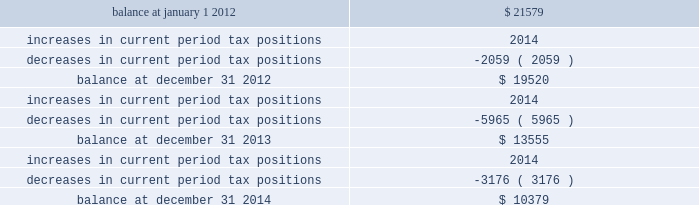Majority of the increased tax position is attributable to temporary differences .
The increase in 2014 current period tax positions related primarily to the company 2019s change in tax accounting method filed in 2008 for repair and maintenance costs on its utility plant .
The company does not anticipate material changes to its unrecognized tax benefits within the next year .
If the company sustains all of its positions at december 31 , 2014 and 2013 , an unrecognized tax benefit of $ 9444 and $ 7439 , respectively , excluding interest and penalties , would impact the company 2019s effective tax rate .
The table summarizes the changes in the company 2019s valuation allowance: .
Included in 2013 is a discrete tax benefit totaling $ 2979 associated with an entity re-organization within the company 2019s market-based operations segment that allowed for the utilization of state net operating loss carryforwards and the release of an associated valuation allowance .
Note 13 : employee benefits pension and other postretirement benefits the company maintains noncontributory defined benefit pension plans covering eligible employees of its regulated utility and shared services operations .
Benefits under the plans are based on the employee 2019s years of service and compensation .
The pension plans have been closed for all employees .
The pension plans were closed for most employees hired on or after january 1 , 2006 .
Union employees hired on or after january 1 , 2001 had their accrued benefit frozen and will be able to receive this benefit as a lump sum upon termination or retirement .
Union employees hired on or after january 1 , 2001 and non-union employees hired on or after january 1 , 2006 are provided with a 5.25% ( 5.25 % ) of base pay defined contribution plan .
The company does not participate in a multiemployer plan .
The company 2019s pension funding practice is to contribute at least the greater of the minimum amount required by the employee retirement income security act of 1974 or the normal cost .
Further , the company will consider additional contributions if needed to avoid 201cat risk 201d status and benefit restrictions under the pension protection act of 2006 .
The company may also consider increased contributions , based on other financial requirements and the plans 2019 funded position .
Pension plan assets are invested in a number of actively managed and commingled funds including equity and bond funds , fixed income securities , guaranteed interest contracts with insurance companies , real estate funds and real estate investment trusts ( 201creits 201d ) .
Pension expense in excess of the amount contributed to the pension plans is deferred by certain regulated subsidiaries pending future recovery in rates charged for utility services as contributions are made to the plans .
( see note 6 ) the company also has unfunded noncontributory supplemental non-qualified pension plans that provide additional retirement benefits to certain employees. .
What percentage of the company 2019s valuation allowance consisted of a discrete tax benefit in 2013? 
Computations: (2979 / 13555)
Answer: 0.21977. 